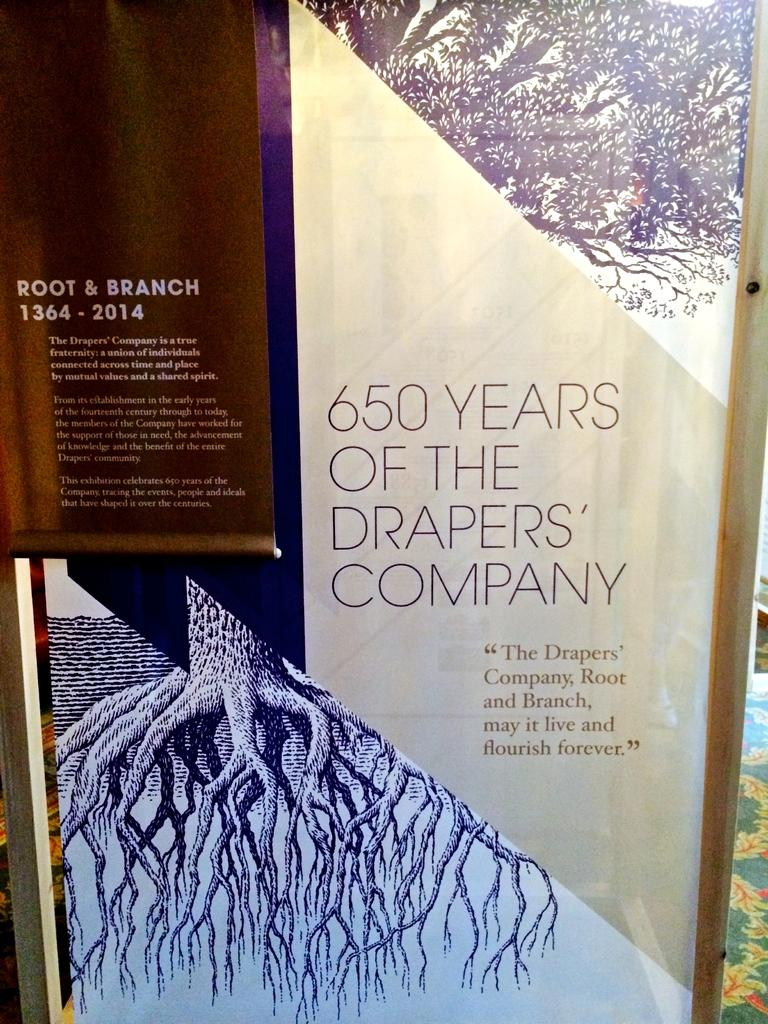<image>
Provide a brief description of the given image. A sign that reads "650 years of the Drapers' Company" 